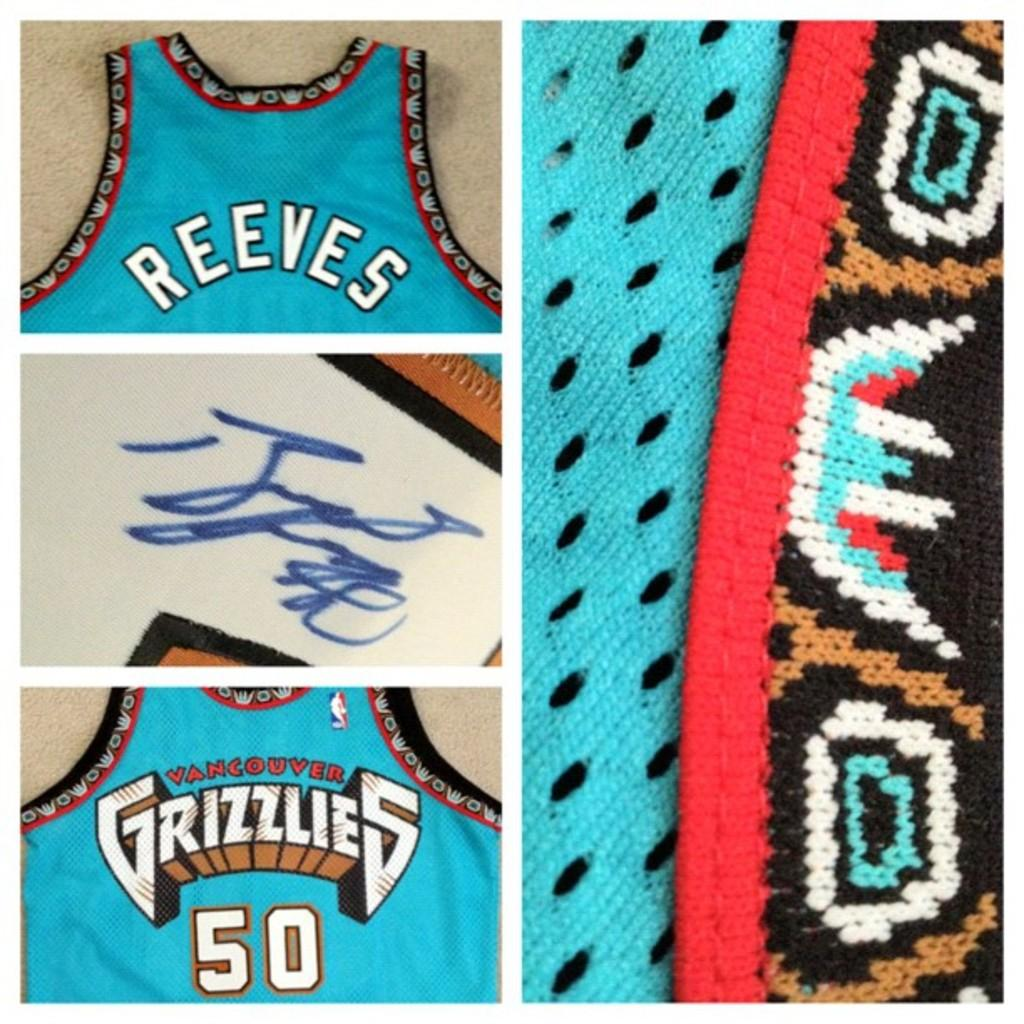<image>
Provide a brief description of the given image. A Grizzlies jersey has 50 and the name Reeves. 